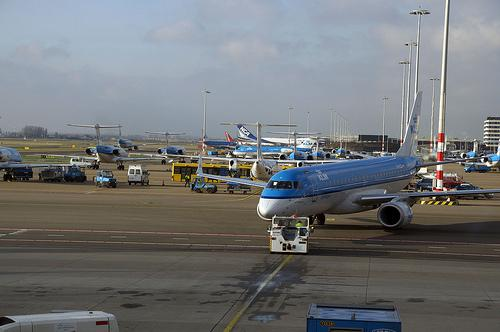Question: what is on the ground besides planes?
Choices:
A. People.
B. Trucks.
C. Carts.
D. Vehicles.
Answer with the letter. Answer: D Question: what color are the planes?
Choices:
A. Red and black.
B. Blue and white.
C. Orange and yellow.
D. Pink and purple.
Answer with the letter. Answer: B Question: what is in the sky?
Choices:
A. Planes.
B. Birds.
C. Balloons.
D. Clouds.
Answer with the letter. Answer: D Question: where are the planes?
Choices:
A. The sky.
B. An airport.
C. A runway.
D. Taking off.
Answer with the letter. Answer: B 